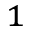Convert formula to latex. <formula><loc_0><loc_0><loc_500><loc_500>^ { 1 }</formula> 